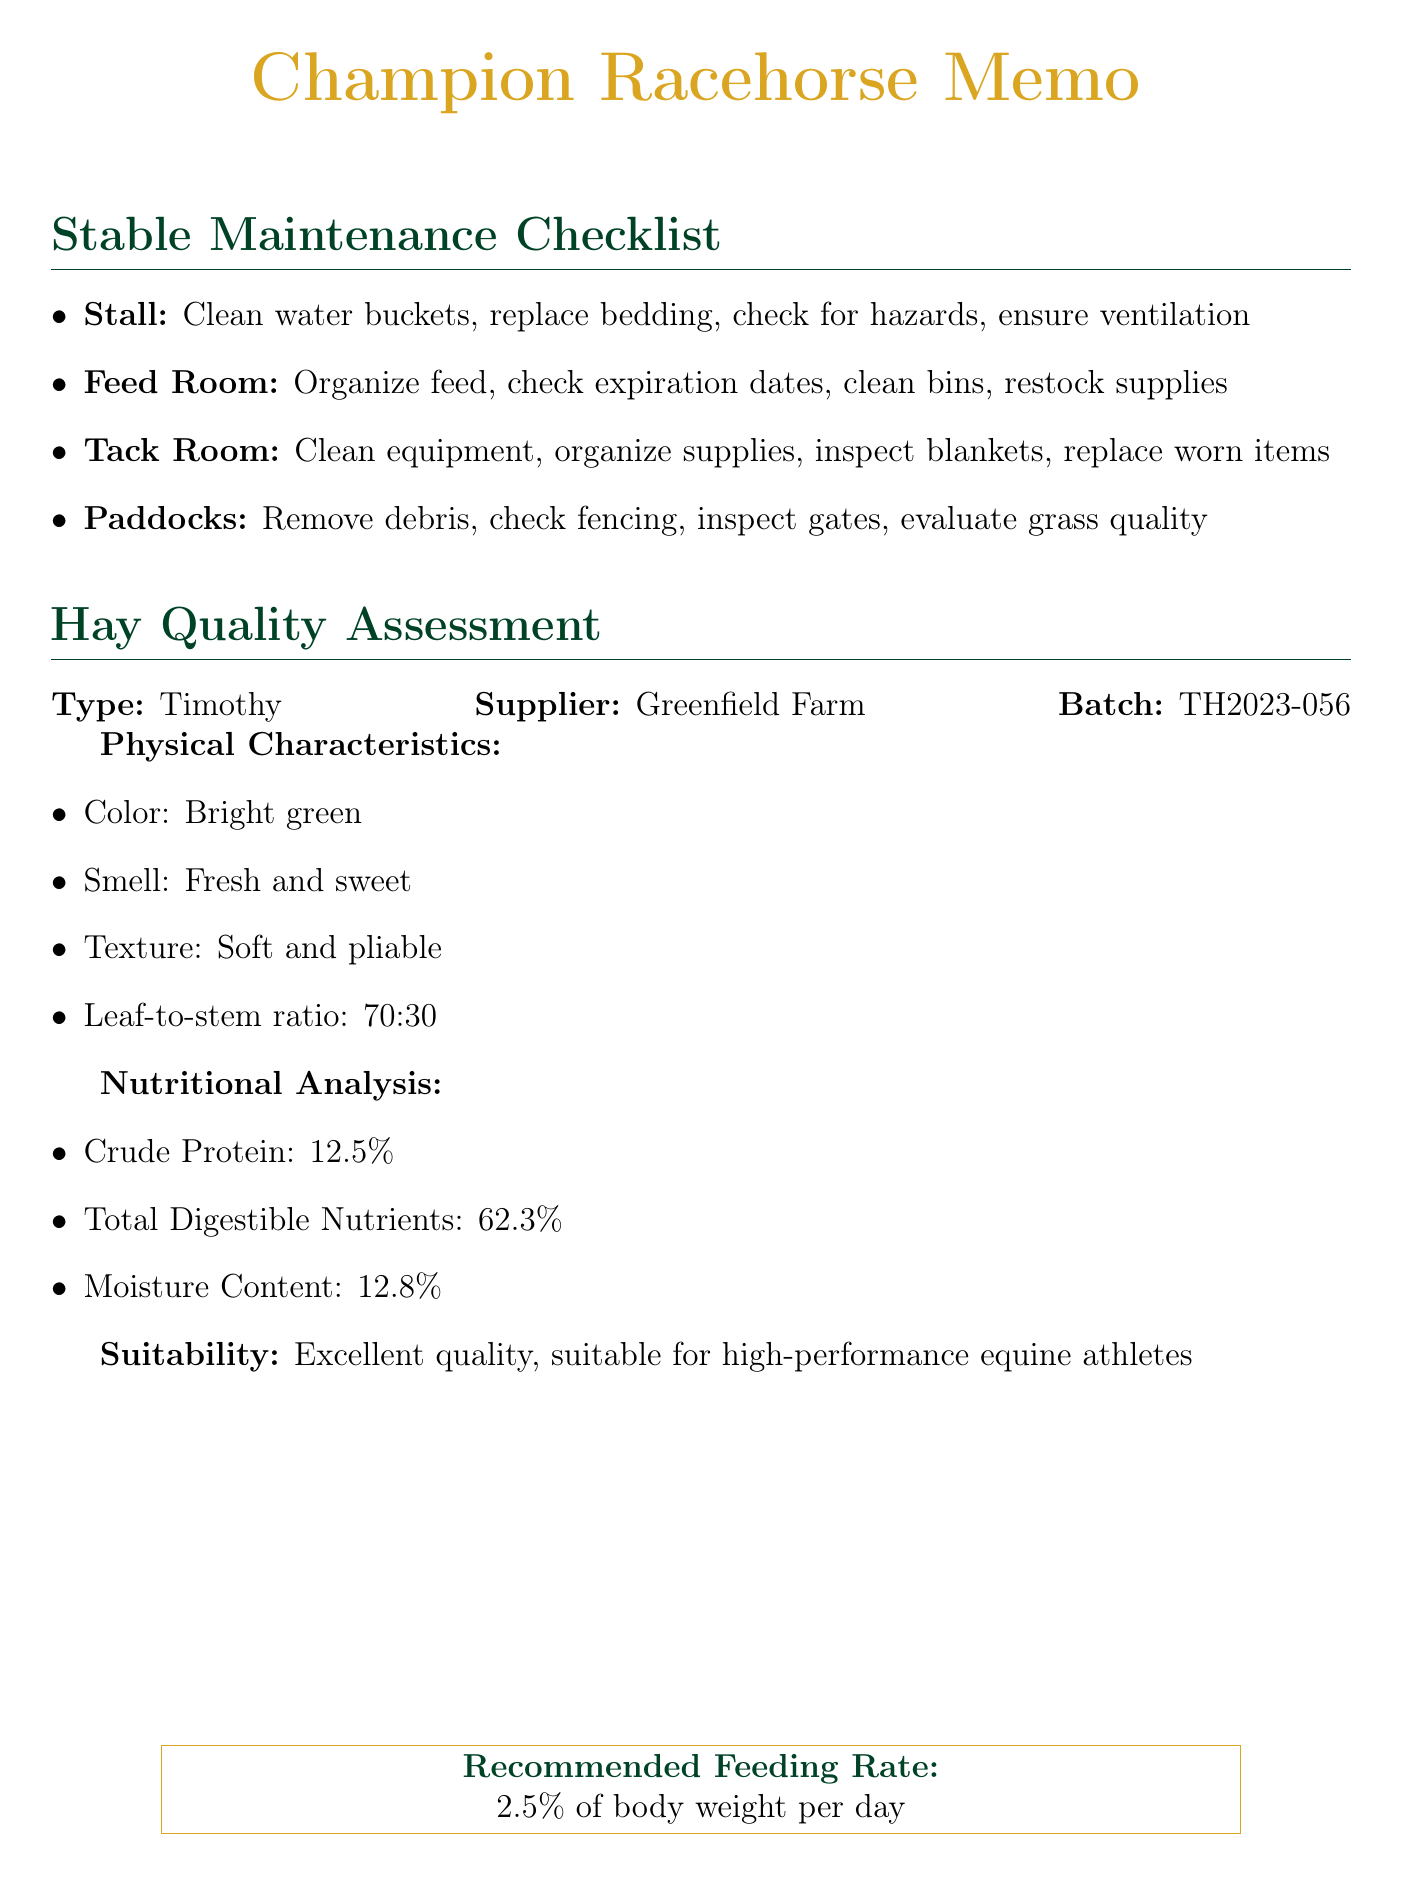What is the color of the Timothy hay? The color of the Timothy hay is specified in the report's physical characteristics section.
Answer: Bright green Who is the supplier of the hay? The supplier's name is provided in the hay quality assessment report.
Answer: Greenfield Farm What is the batch number of the hay? The batch number is listed in the hay quality assessment report.
Answer: TH2023-056 What is the recommended feeding rate for the hay? The recommended feeding rate is provided in the recommendations section of the memo.
Answer: 2.5% of body weight per day How much crude protein is in the Timothy hay? The amount of crude protein is included in the nutritional analysis of the hay quality assessment report.
Answer: 12.5% What tasks should be performed in the feed room? Tasks in the feed room are detailed in the stable maintenance checklist.
Answer: Organize feed bags and supplements, check expiration dates on all feed, clean and sanitize feed bins, ensure proper storage of medications, restock first aid kit Is the hay suitable for high-performance equine athletes? Suitability for racehorses is stated in the hay quality assessment report.
Answer: Excellent quality, suitable for high-performance equine athletes What is the leaf-to-stem ratio of the hay? The leaf-to-stem ratio is one of the physical characteristics specified in the assessment report.
Answer: 70:30 What condition should the paddocks be assessed for? The condition that needs to be checked in the paddocks is outlined in the stable maintenance checklist.
Answer: Signs of overgrazing or erosion 